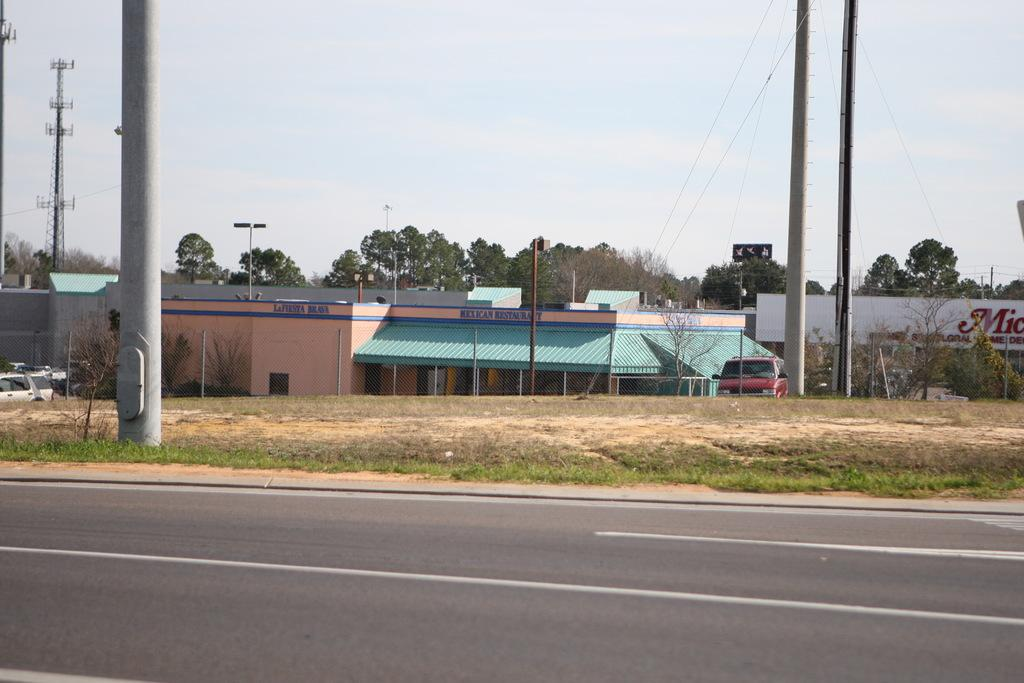What is the main feature of the image? There is a road in the image. What can be seen on the ground? The ground is visible in the image, and there is grass on it. What structures are present in the image? There are poles, a car, buildings, and a tower in the image. What type of vegetation is visible in the background? There are trees in the background of the image. What is visible in the sky? The sky is visible in the background of the image. What year is depicted in the image? The image does not depict a specific year; it is a photograph of a scene that could be from any time. Where is the shelf located in the image? There is no shelf present in the image. 